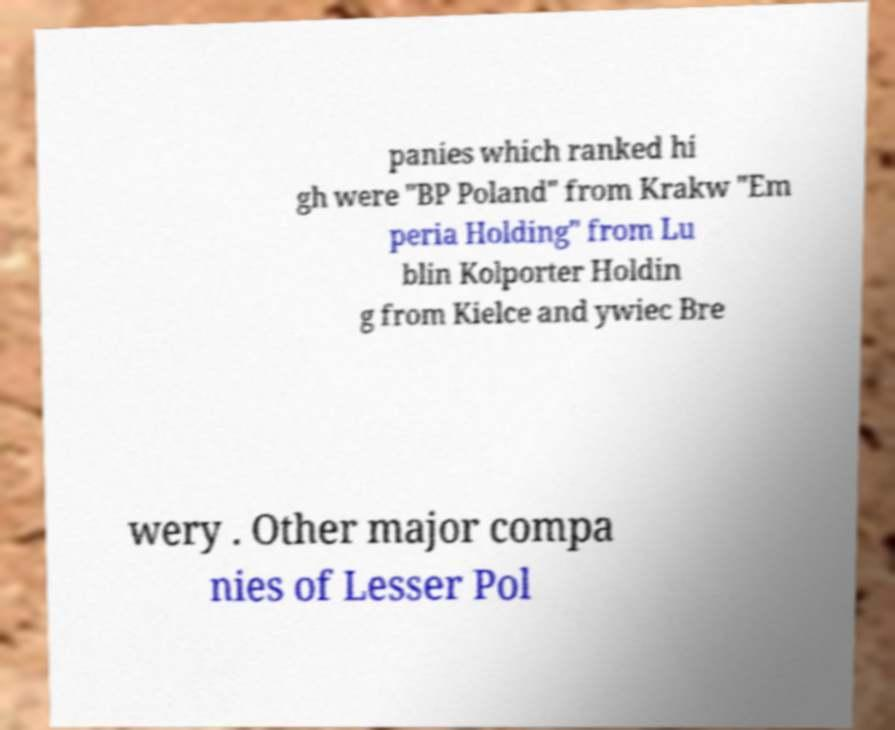Can you read and provide the text displayed in the image?This photo seems to have some interesting text. Can you extract and type it out for me? panies which ranked hi gh were "BP Poland" from Krakw "Em peria Holding" from Lu blin Kolporter Holdin g from Kielce and ywiec Bre wery . Other major compa nies of Lesser Pol 